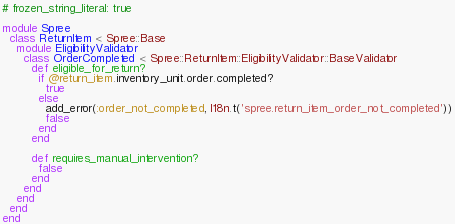Convert code to text. <code><loc_0><loc_0><loc_500><loc_500><_Ruby_># frozen_string_literal: true

module Spree
  class ReturnItem < Spree::Base
    module EligibilityValidator
      class OrderCompleted < Spree::ReturnItem::EligibilityValidator::BaseValidator
        def eligible_for_return?
          if @return_item.inventory_unit.order.completed?
            true
          else
            add_error(:order_not_completed, I18n.t('spree.return_item_order_not_completed'))
            false
          end
        end

        def requires_manual_intervention?
          false
        end
      end
    end
  end
end
</code> 